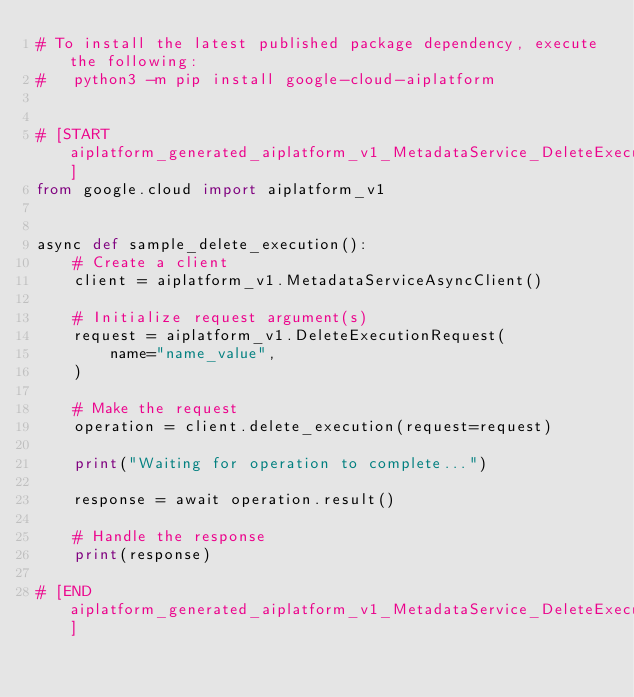Convert code to text. <code><loc_0><loc_0><loc_500><loc_500><_Python_># To install the latest published package dependency, execute the following:
#   python3 -m pip install google-cloud-aiplatform


# [START aiplatform_generated_aiplatform_v1_MetadataService_DeleteExecution_async]
from google.cloud import aiplatform_v1


async def sample_delete_execution():
    # Create a client
    client = aiplatform_v1.MetadataServiceAsyncClient()

    # Initialize request argument(s)
    request = aiplatform_v1.DeleteExecutionRequest(
        name="name_value",
    )

    # Make the request
    operation = client.delete_execution(request=request)

    print("Waiting for operation to complete...")

    response = await operation.result()

    # Handle the response
    print(response)

# [END aiplatform_generated_aiplatform_v1_MetadataService_DeleteExecution_async]
</code> 